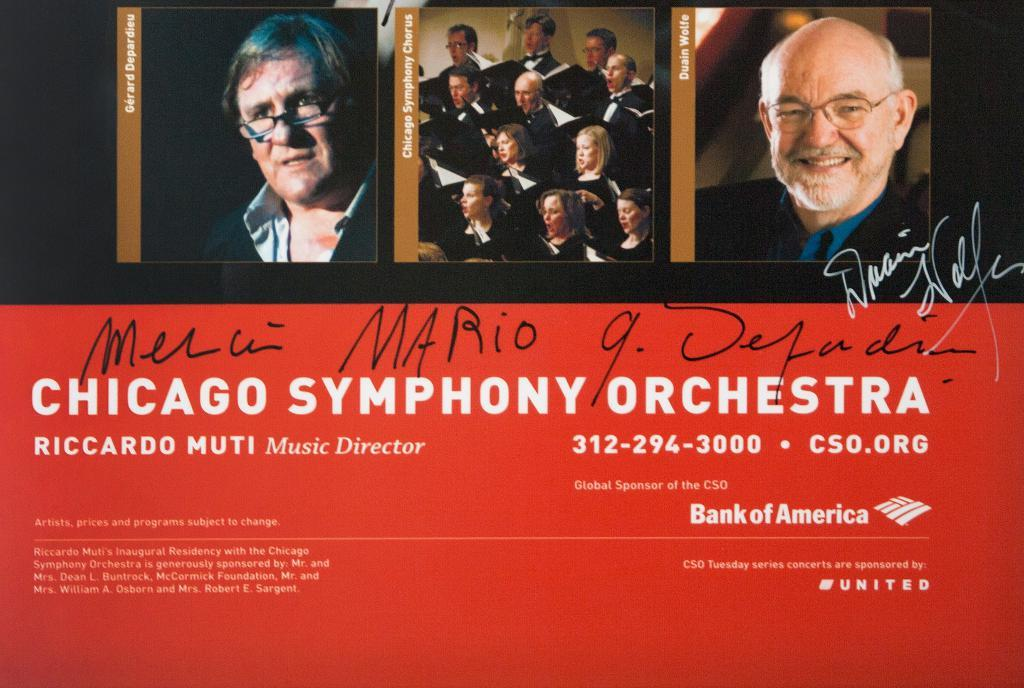What is located at the top of the poster? There are people at the top of the poster. What can be found at the bottom of the poster? There is text at the bottom of the poster. What type of news is being reported by the plate in the image? There is no plate present in the image, and therefore no news can be reported by it. What emotion do the people at the top of the poster feel about their past decisions? The provided facts do not mention any emotions or past decisions, so we cannot determine how the people feel about their past decisions. 